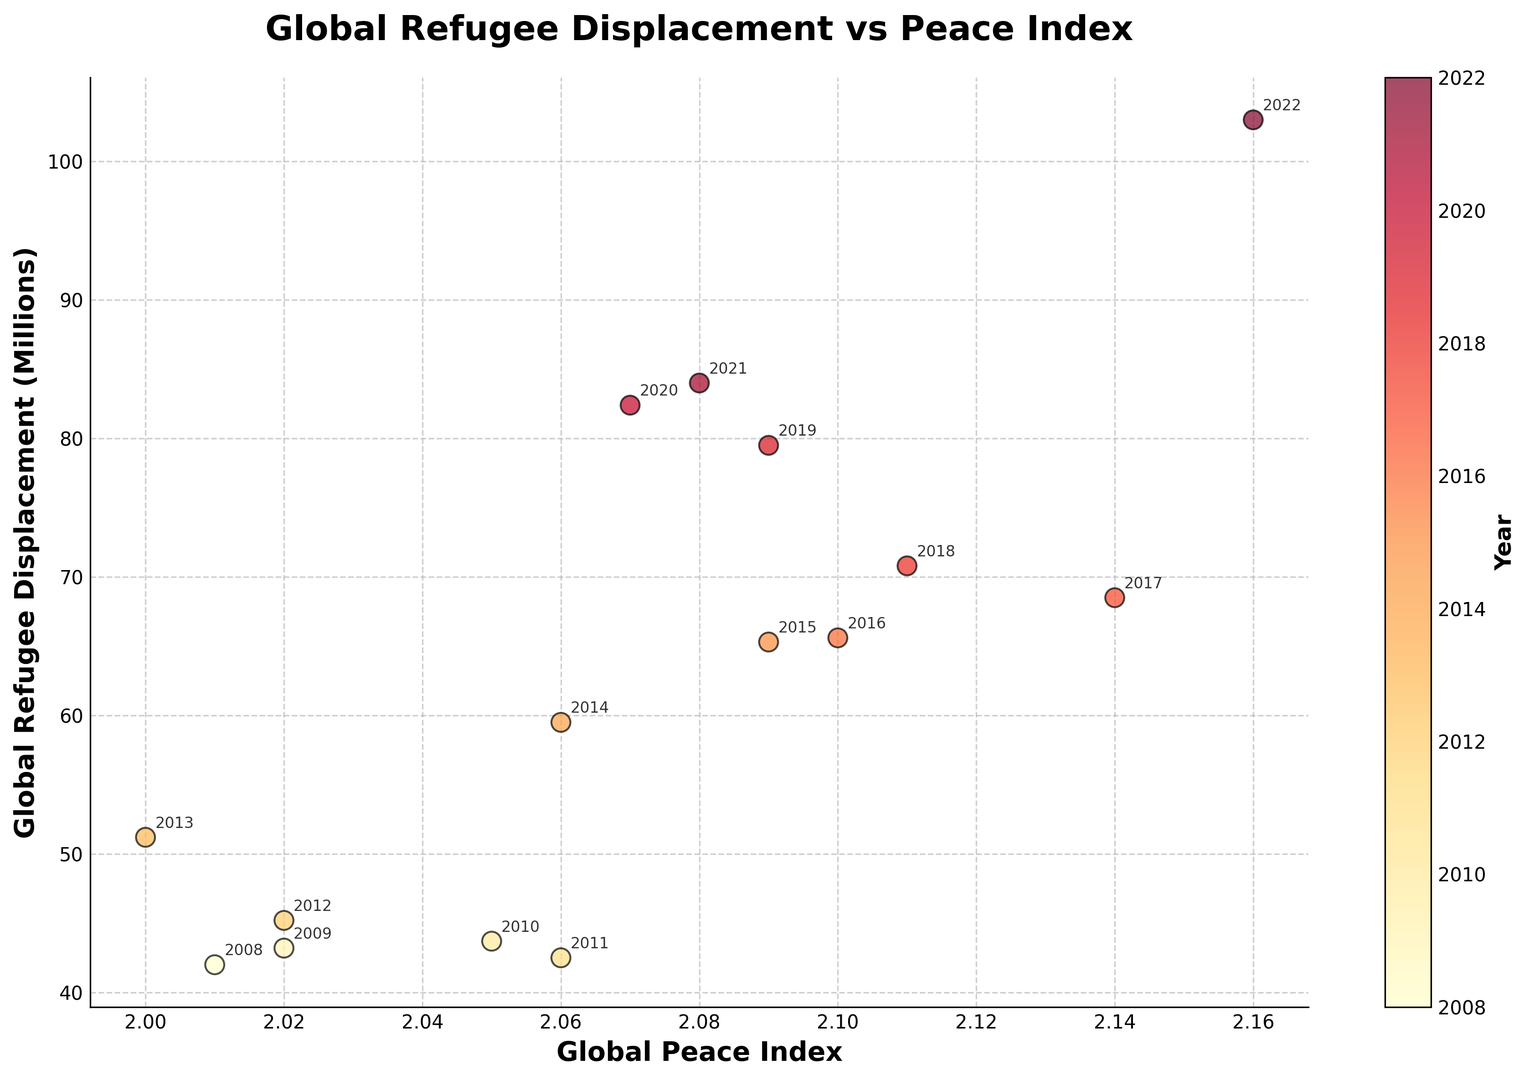What is the trend of global refugee displacement from 2008 to 2022? From the figure, we see that the scatter points generally ascend over the years from 2008 to 2022, indicating a rising trend in global refugee displacement.
Answer: Rising trend Which year had the lowest global peace index, and what was its corresponding refugee displacement? The year 2013 has the lowest global peace index (2.00) as seen from the x-axis, and its corresponding refugee displacement is approximately 51.2 million.
Answer: 2013, 51.2 million Is there a correlation between increasing global peace index scores and global refugee displacement? Observing the scatter plot, there is a visual trend that shows higher global peace index scores tend to coincide with higher levels of global refugee displacement. This suggests a positive correlation.
Answer: Positive correlation Which two consecutive years have the most significant increase in displacement? By analyzing the annotated dots and their positions, the years 2021 and 2022 show the most significant increase in displacement from approximately 84 million to 103 million, a difference of 19 million.
Answer: 2021 to 2022 At a peace index score of approximately 2.10, how does the refugee displacement vary? For 2.10 on the x-axis, the dot shifts vertically for different refugee displacements, representing the years 2016 (~65.6 million) and 2019 (~79.5 million). It shows that at 2.10, displacements can vary by almost 14 million.
Answer: Varies by 14 million (65.6 to 79.5 million) What does the color gradient in the scatter plot represent? The scatter plot's color gradient ranges from yellow to red, denoting different years, with yellow representing earlier years (2008) and red signifying later years (2022). This can be inferred from the color bar.
Answer: Years Do the scatter points indicate a general increase or decrease in global peace over the years? By examining the colors from yellow in earlier years (lower GPI scores) to darker red in later years (higher GPI scores), the scatter points indicate a general decrease in global peace over the years.
Answer: Decrease Which year had the highest global refugee displacement, and what was its corresponding peace index score? The year 2022 has the highest global refugee displacement (~103 million) according to the y-axis, with a corresponding peace index score of 2.16 as seen from the x-axis.
Answer: 2022, 2.16 